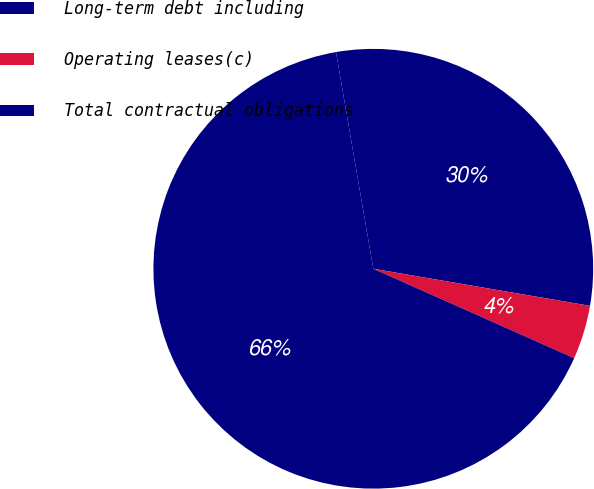Convert chart. <chart><loc_0><loc_0><loc_500><loc_500><pie_chart><fcel>Long-term debt including<fcel>Operating leases(c)<fcel>Total contractual obligations<nl><fcel>30.41%<fcel>3.97%<fcel>65.62%<nl></chart> 